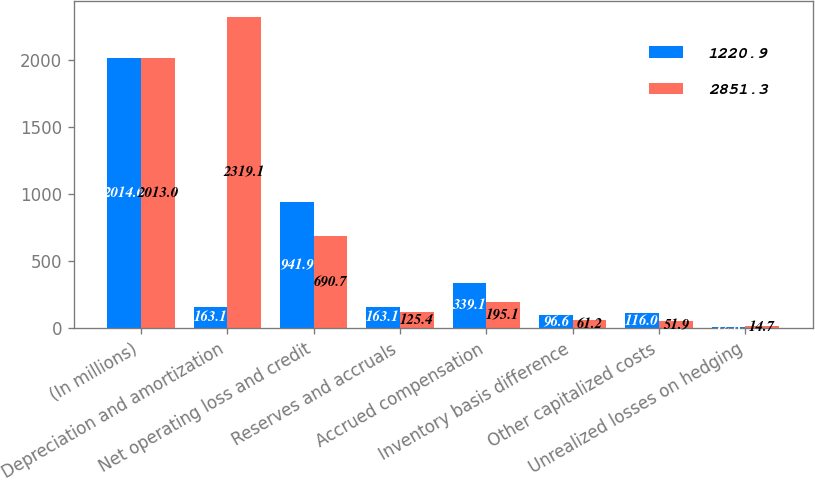Convert chart. <chart><loc_0><loc_0><loc_500><loc_500><stacked_bar_chart><ecel><fcel>(In millions)<fcel>Depreciation and amortization<fcel>Net operating loss and credit<fcel>Reserves and accruals<fcel>Accrued compensation<fcel>Inventory basis difference<fcel>Other capitalized costs<fcel>Unrealized losses on hedging<nl><fcel>1220.9<fcel>2014<fcel>163.1<fcel>941.9<fcel>163.1<fcel>339.1<fcel>96.6<fcel>116<fcel>12.8<nl><fcel>2851.3<fcel>2013<fcel>2319.1<fcel>690.7<fcel>125.4<fcel>195.1<fcel>61.2<fcel>51.9<fcel>14.7<nl></chart> 